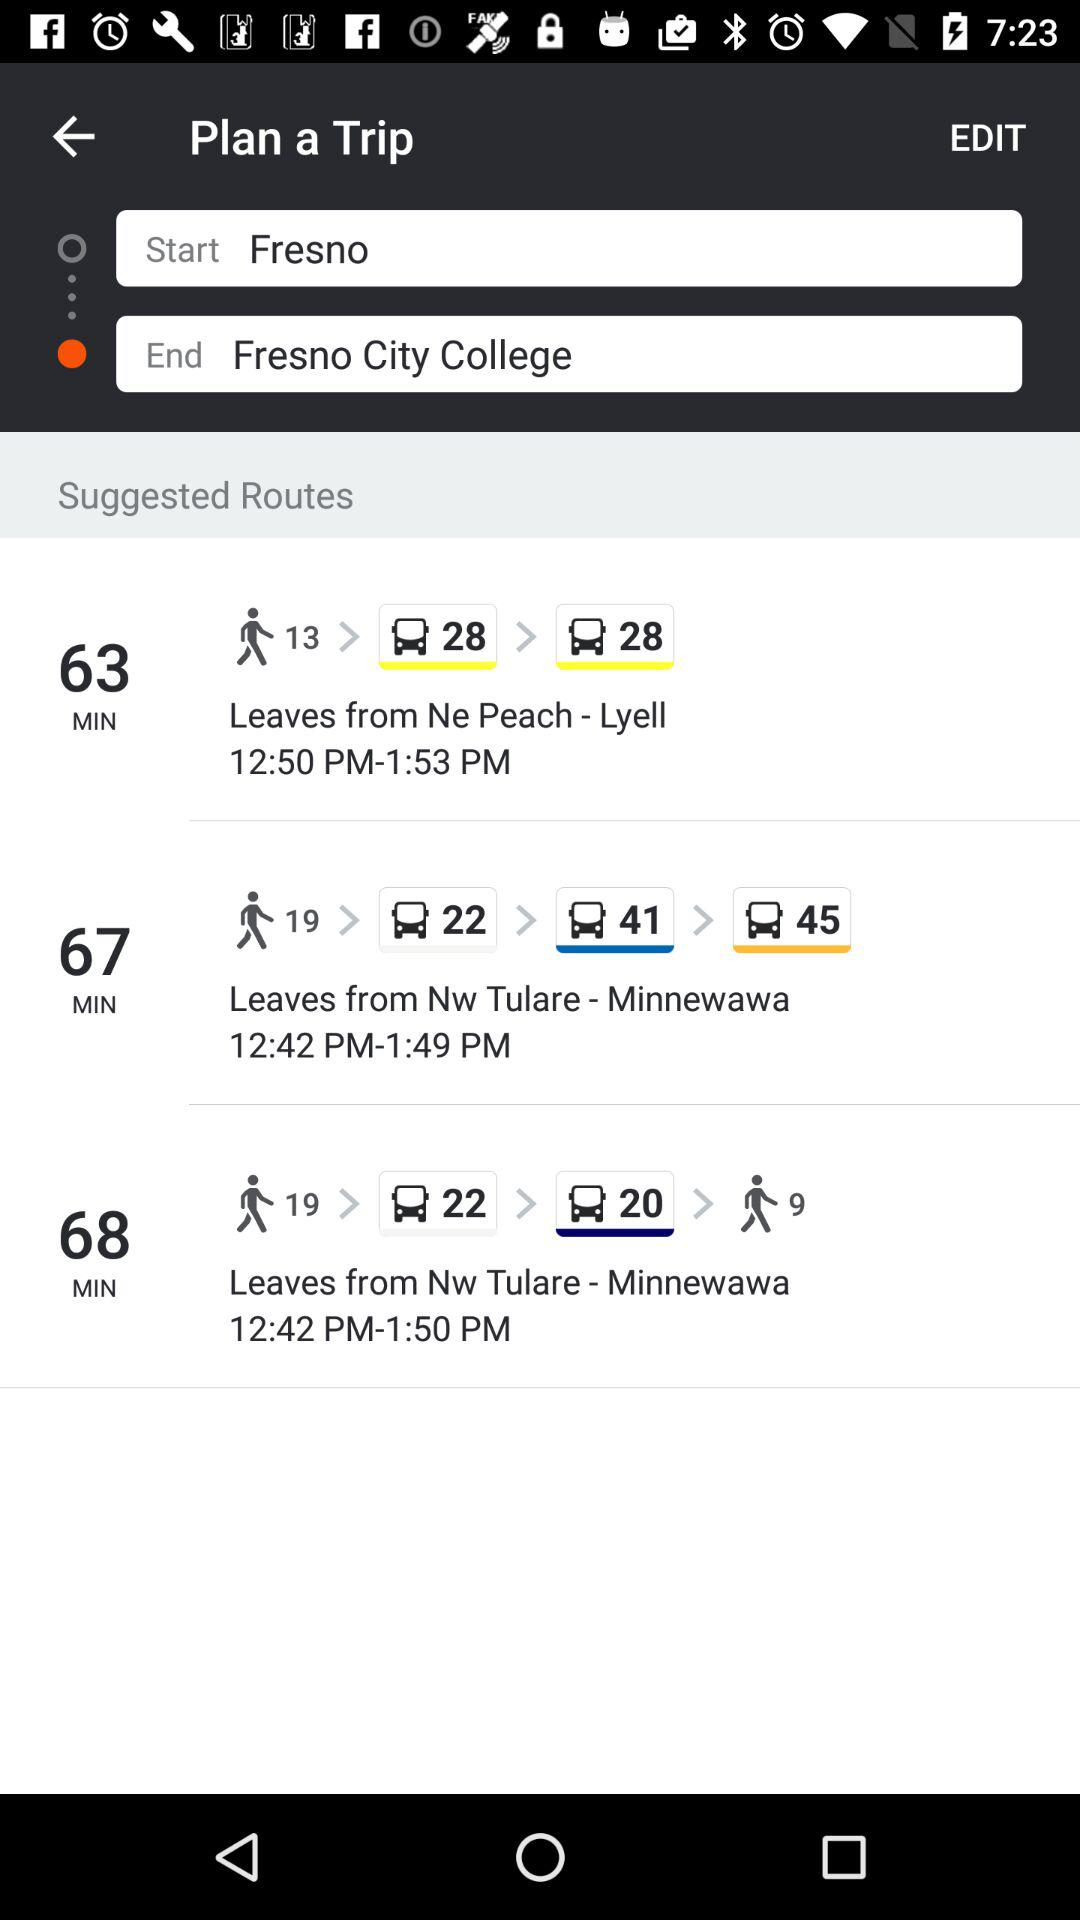At what time does the bus leave from "Ne Peach"? The bus leaves at 12:50 PM. 